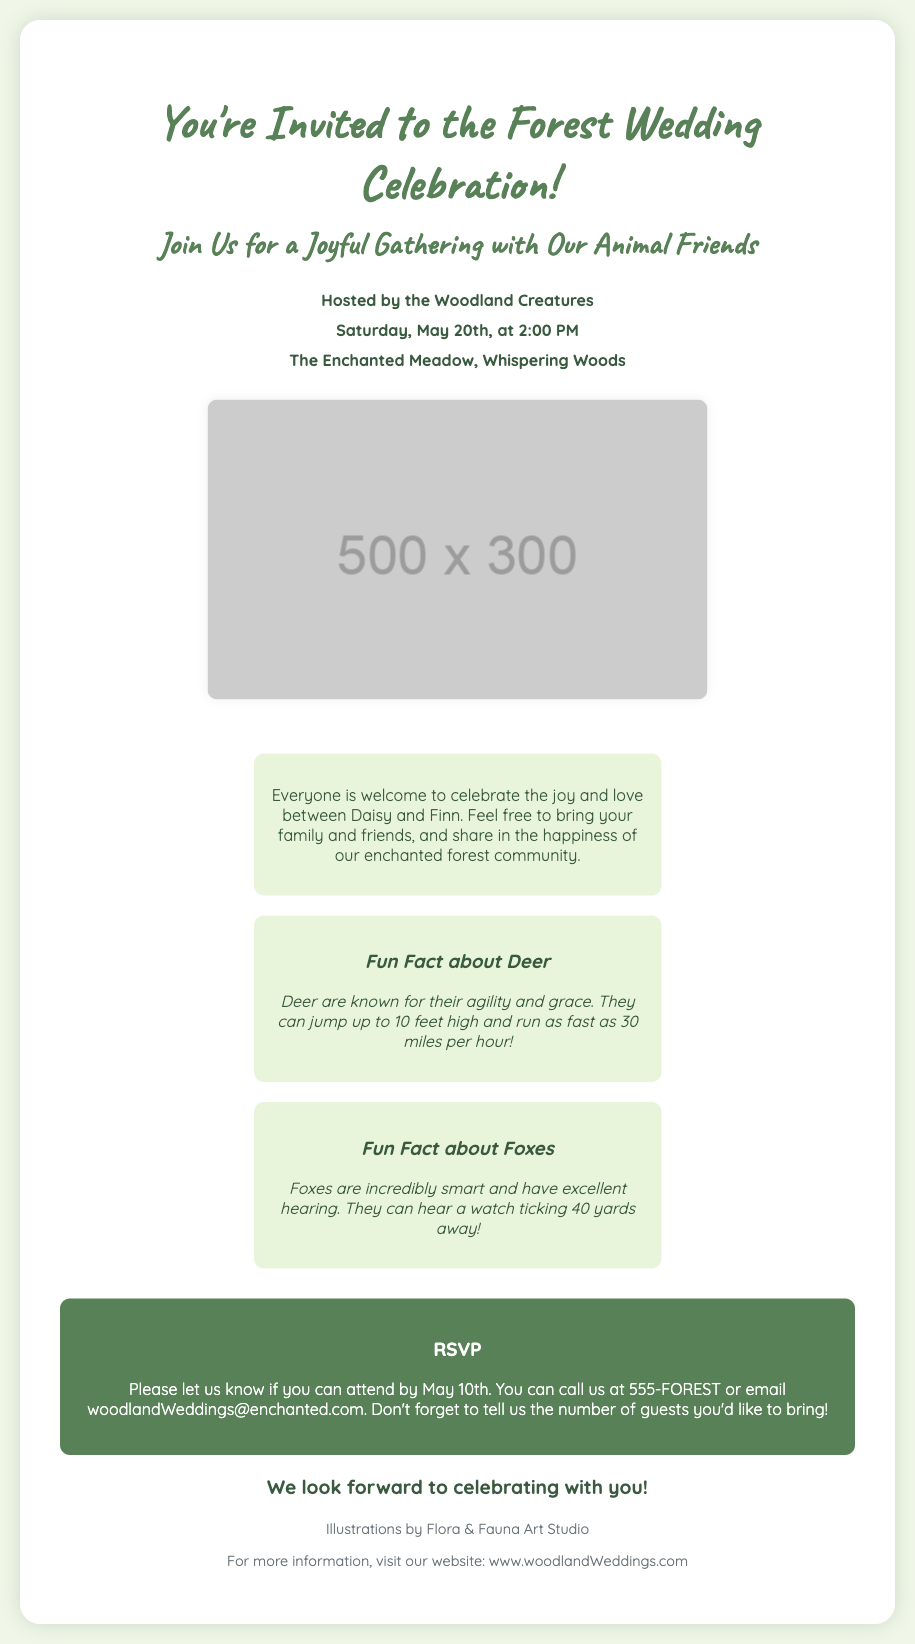What is the event being celebrated? The event being celebrated is a wedding, as indicated in the invitation.
Answer: Wedding Who are the hosts of the celebration? The hosts of the celebration are mentioned in the invitation.
Answer: Woodland Creatures What is the date of the wedding celebration? The specific date of the celebration is noted in the invitation.
Answer: Saturday, May 20th What is the location of the event? The invitation specifies the location where the celebration will take place.
Answer: The Enchanted Meadow, Whispering Woods How many fun facts are included about animals? The document lists the number of fun facts provided.
Answer: Two What animal is Daisy associated with? The invitation refers to a character named Daisy, who is presumably a deer based on the animal-related facts.
Answer: Deer What should guests do by May 10th? The invitation specifies an action that guests are required to complete by this date.
Answer: RSVP What is the email address for RSVPs? The invitation provides an email address to contact for RSVPs.
Answer: woodlandWeddings@enchanted.com What type of illustrations are featured in the invitation? The document describes the type of illustrations included in the wedding invitation.
Answer: Charming and child-friendly illustrations of forest animals 